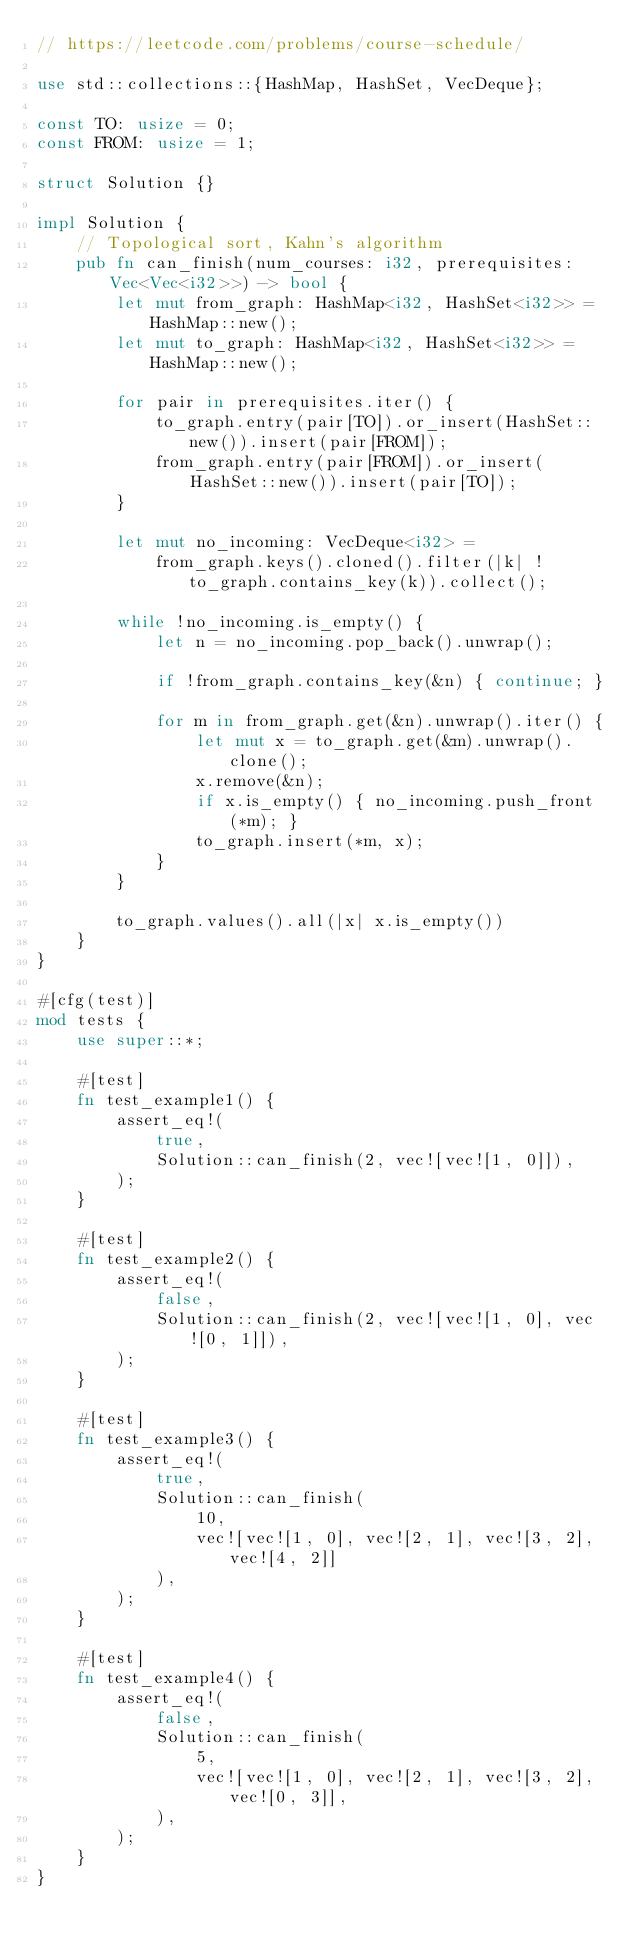Convert code to text. <code><loc_0><loc_0><loc_500><loc_500><_Rust_>// https://leetcode.com/problems/course-schedule/

use std::collections::{HashMap, HashSet, VecDeque};

const TO: usize = 0;
const FROM: usize = 1;

struct Solution {}

impl Solution {
    // Topological sort, Kahn's algorithm
    pub fn can_finish(num_courses: i32, prerequisites: Vec<Vec<i32>>) -> bool {
        let mut from_graph: HashMap<i32, HashSet<i32>> = HashMap::new();
        let mut to_graph: HashMap<i32, HashSet<i32>> = HashMap::new();
        
        for pair in prerequisites.iter() {
            to_graph.entry(pair[TO]).or_insert(HashSet::new()).insert(pair[FROM]);
            from_graph.entry(pair[FROM]).or_insert(HashSet::new()).insert(pair[TO]);
        }

        let mut no_incoming: VecDeque<i32> =
            from_graph.keys().cloned().filter(|k| !to_graph.contains_key(k)).collect();

        while !no_incoming.is_empty() {
            let n = no_incoming.pop_back().unwrap();

            if !from_graph.contains_key(&n) { continue; }

            for m in from_graph.get(&n).unwrap().iter() {
                let mut x = to_graph.get(&m).unwrap().clone();
                x.remove(&n);
                if x.is_empty() { no_incoming.push_front(*m); }
                to_graph.insert(*m, x);
            }
        }

        to_graph.values().all(|x| x.is_empty())
    }
}

#[cfg(test)]
mod tests {
    use super::*;

    #[test]
    fn test_example1() {
        assert_eq!(
            true,
            Solution::can_finish(2, vec![vec![1, 0]]),
        );
    }

    #[test]
    fn test_example2() {
        assert_eq!(
            false,
            Solution::can_finish(2, vec![vec![1, 0], vec![0, 1]]),
        );
    }

    #[test]
    fn test_example3() {
        assert_eq!(
            true,
            Solution::can_finish(
                10,
                vec![vec![1, 0], vec![2, 1], vec![3, 2], vec![4, 2]]
            ),
        );
    }

    #[test]
    fn test_example4() {
        assert_eq!(
            false,
            Solution::can_finish(
                5,
                vec![vec![1, 0], vec![2, 1], vec![3, 2], vec![0, 3]],
            ),
        );
    }
}
</code> 